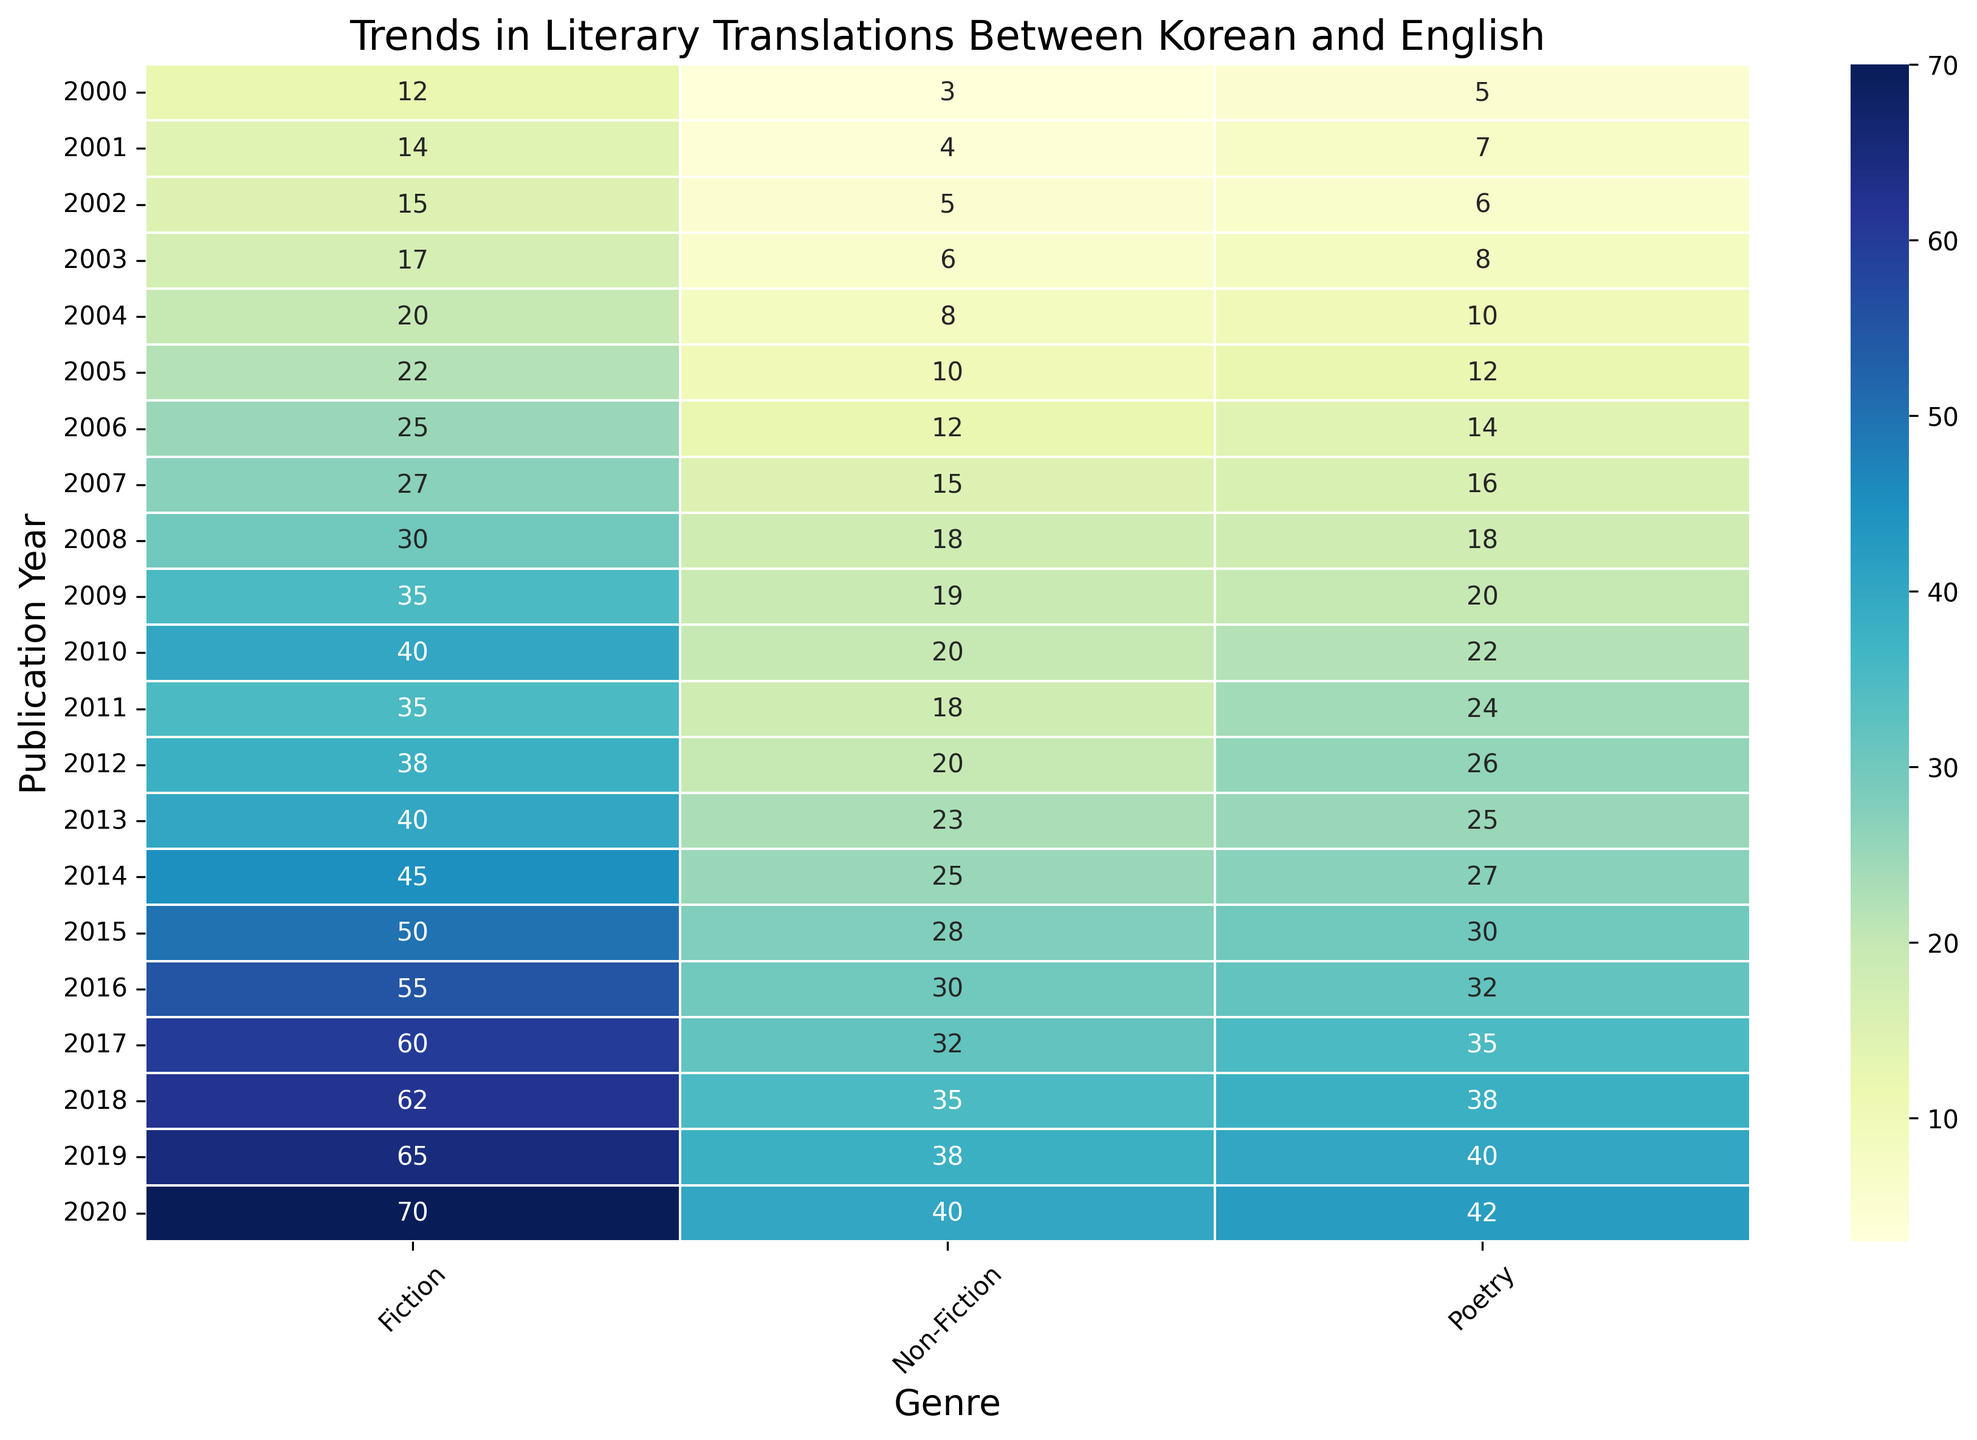What genre had the highest number of translations in 2020? By looking at the heatmap, identify the count of the highest value for each genre in 2020. Fiction had the highest count with 70 translations.
Answer: Fiction How did the number of fiction translations in 2000 compare to 2010? Find the counts for fiction in 2000 and 2010. In 2000, the count was 12, and in 2010 it was 40. Therefore, it increased by 28.
Answer: 28 What is the sum of translations for Non-Fiction in the years 2015 and 2018? Add the counts for Non-Fiction in 2015 and 2018. In 2015, the count was 28, and in 2018 it was 35. The total is 28 + 35 = 63.
Answer: 63 In which year was the number of poetry translations closest to 20? Check the counts for poetry each year and find the closest to 20. In 2009, the number of poetry translations was exactly 20.
Answer: 2009 Which genre shows the greatest increase in translations from 2000 to 2020? By comparing the counts for each genre in 2000 and 2020, find the difference: Fiction increased from 12 to 70 (by 58), Poetry from 5 to 42 (by 37), and Non-Fiction from 3 to 40 (by 37). Fiction has the greatest increase.
Answer: Fiction What is the average number of translations for Fiction between 2000 to 2004? Find the counts of Fiction from 2000 to 2004: (12 + 14 + 15 + 17 + 20). Sum them to get 78, and divide by 5, the total number of years. The average is 78/5 = 15.6.
Answer: 15.6 Between Poetry and Non-Fiction, which genre had more translations in 2012? Compare the counts for Poetry and Non-Fiction in 2012. Poetry had 26 translations, and Non-Fiction had 20. Poetry had more translations.
Answer: Poetry What is the difference in the count of total translations (all genres combined) between 2005 and 2015? Calculate the total translations for all genres each year: 
2005: Poetry (12) + Fiction (22) + Non-Fiction (10) = 44.
2015: Poetry (30) + Fiction (50) + Non-Fiction (28) = 108.
The difference is 108 - 44 = 64.
Answer: 64 